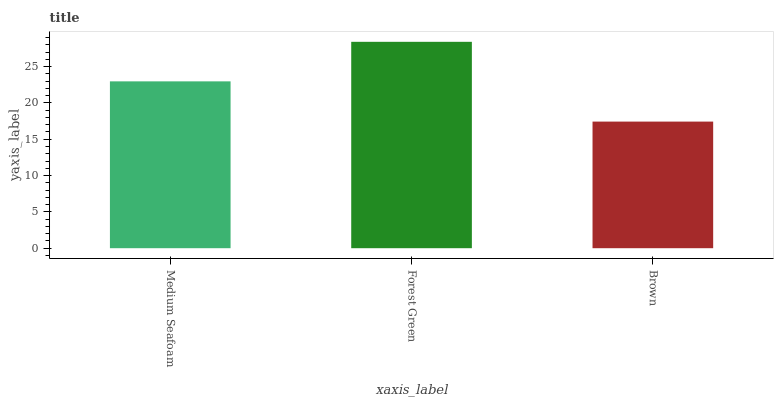Is Forest Green the minimum?
Answer yes or no. No. Is Brown the maximum?
Answer yes or no. No. Is Forest Green greater than Brown?
Answer yes or no. Yes. Is Brown less than Forest Green?
Answer yes or no. Yes. Is Brown greater than Forest Green?
Answer yes or no. No. Is Forest Green less than Brown?
Answer yes or no. No. Is Medium Seafoam the high median?
Answer yes or no. Yes. Is Medium Seafoam the low median?
Answer yes or no. Yes. Is Forest Green the high median?
Answer yes or no. No. Is Forest Green the low median?
Answer yes or no. No. 